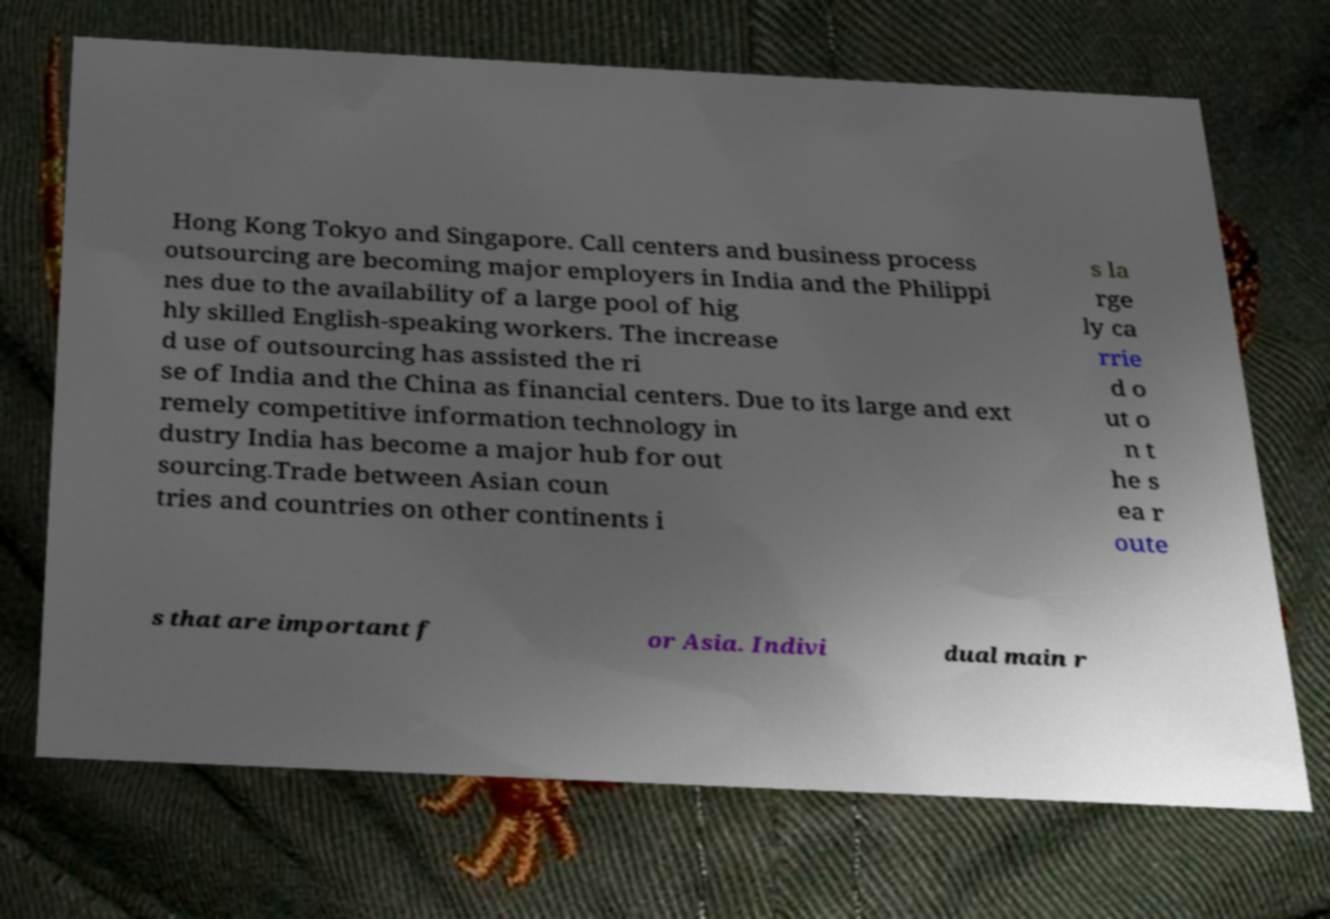Could you extract and type out the text from this image? Hong Kong Tokyo and Singapore. Call centers and business process outsourcing are becoming major employers in India and the Philippi nes due to the availability of a large pool of hig hly skilled English-speaking workers. The increase d use of outsourcing has assisted the ri se of India and the China as financial centers. Due to its large and ext remely competitive information technology in dustry India has become a major hub for out sourcing.Trade between Asian coun tries and countries on other continents i s la rge ly ca rrie d o ut o n t he s ea r oute s that are important f or Asia. Indivi dual main r 